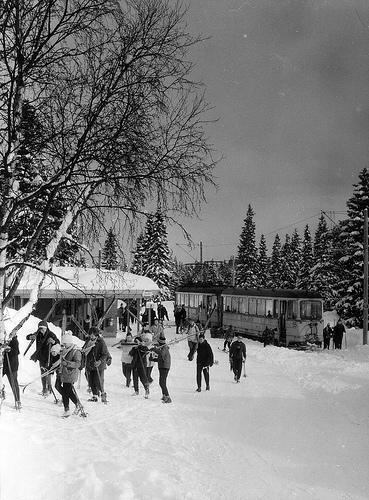How many trolleys are shown in this picture?
Give a very brief answer. 1. How many skiiers are standing to the right of the train car?
Give a very brief answer. 2. 